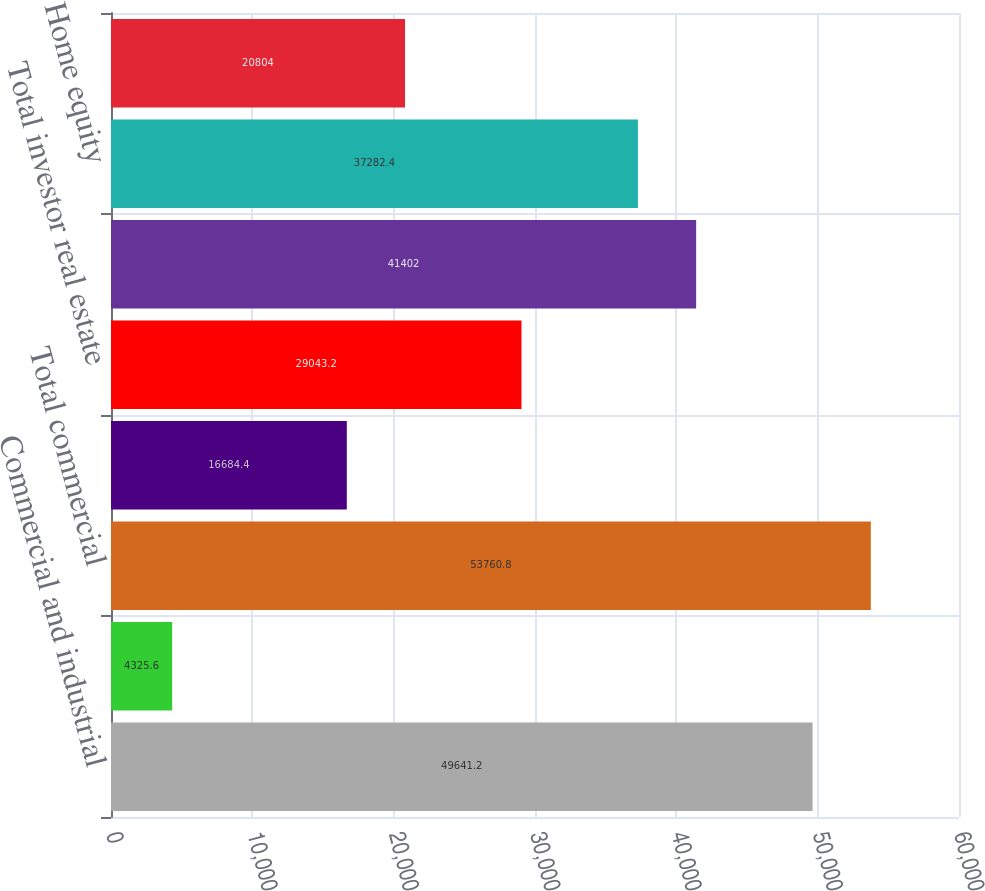Convert chart to OTSL. <chart><loc_0><loc_0><loc_500><loc_500><bar_chart><fcel>Commercial and industrial<fcel>Commercial real estate<fcel>Total commercial<fcel>Commercial investor real<fcel>Total investor real estate<fcel>Residential first mortgage<fcel>Home equity<fcel>Indirect-vehicles<nl><fcel>49641.2<fcel>4325.6<fcel>53760.8<fcel>16684.4<fcel>29043.2<fcel>41402<fcel>37282.4<fcel>20804<nl></chart> 